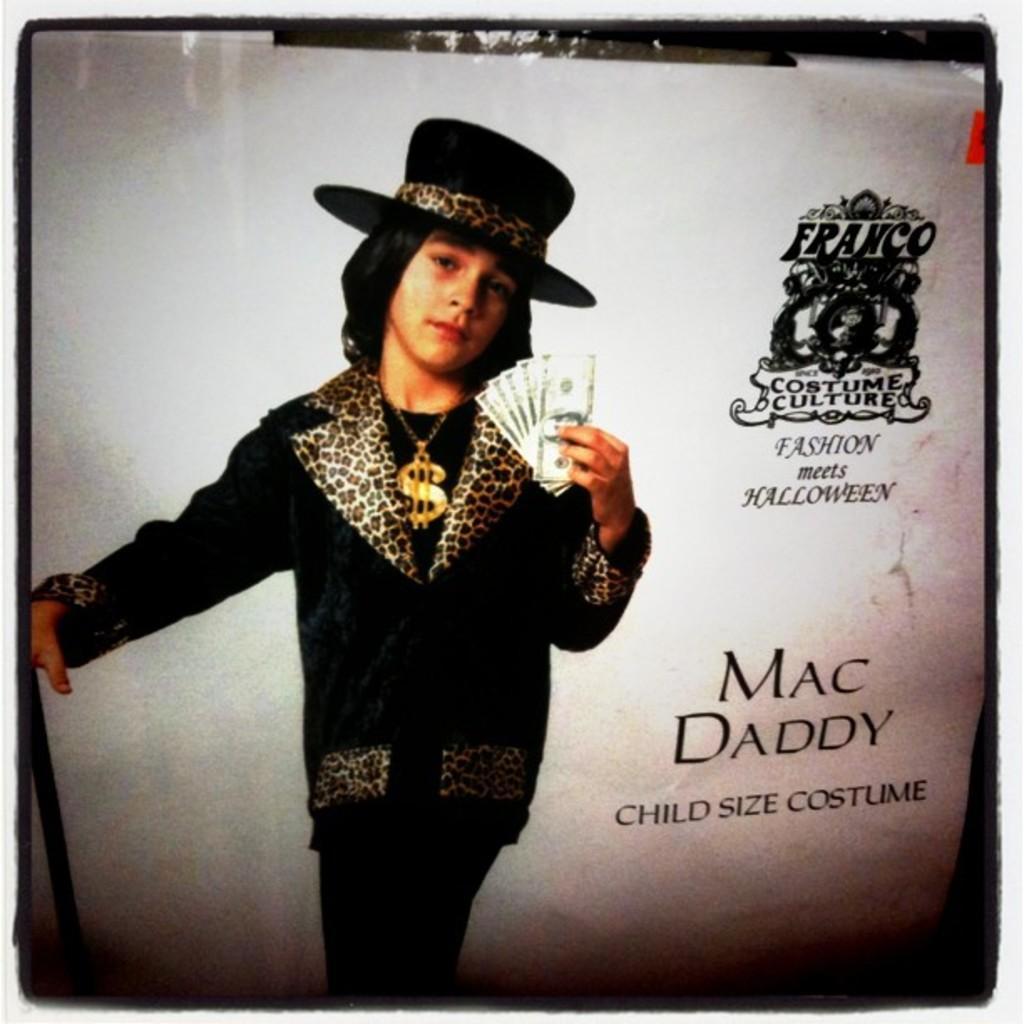Can you describe this image briefly? In this picture I can see the poster. I can see a person wearing a hat and holding currency. I can see texts on it. 